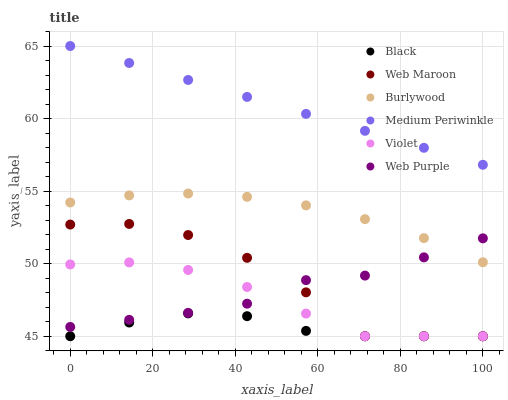Does Black have the minimum area under the curve?
Answer yes or no. Yes. Does Medium Periwinkle have the maximum area under the curve?
Answer yes or no. Yes. Does Web Maroon have the minimum area under the curve?
Answer yes or no. No. Does Web Maroon have the maximum area under the curve?
Answer yes or no. No. Is Medium Periwinkle the smoothest?
Answer yes or no. Yes. Is Web Maroon the roughest?
Answer yes or no. Yes. Is Web Maroon the smoothest?
Answer yes or no. No. Is Medium Periwinkle the roughest?
Answer yes or no. No. Does Web Maroon have the lowest value?
Answer yes or no. Yes. Does Medium Periwinkle have the lowest value?
Answer yes or no. No. Does Medium Periwinkle have the highest value?
Answer yes or no. Yes. Does Web Maroon have the highest value?
Answer yes or no. No. Is Black less than Web Purple?
Answer yes or no. Yes. Is Medium Periwinkle greater than Web Purple?
Answer yes or no. Yes. Does Black intersect Violet?
Answer yes or no. Yes. Is Black less than Violet?
Answer yes or no. No. Is Black greater than Violet?
Answer yes or no. No. Does Black intersect Web Purple?
Answer yes or no. No. 